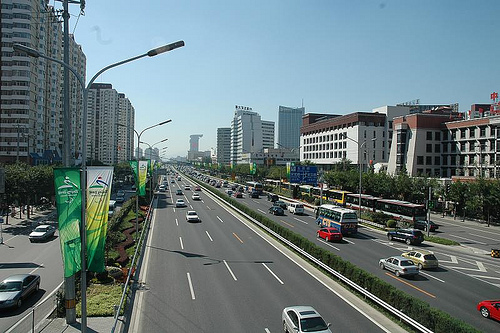<image>
Is the street light above the road? Yes. The street light is positioned above the road in the vertical space, higher up in the scene. 